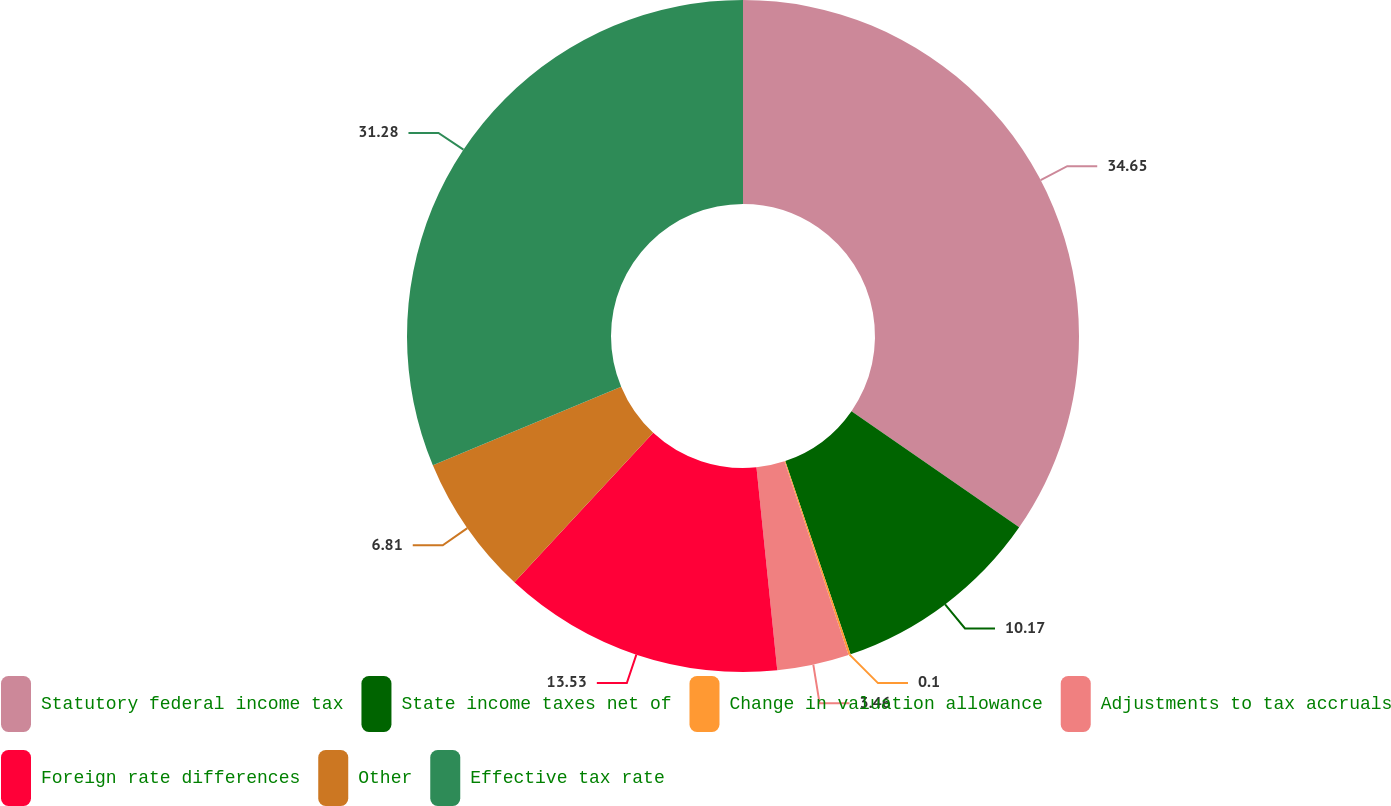<chart> <loc_0><loc_0><loc_500><loc_500><pie_chart><fcel>Statutory federal income tax<fcel>State income taxes net of<fcel>Change in valuation allowance<fcel>Adjustments to tax accruals<fcel>Foreign rate differences<fcel>Other<fcel>Effective tax rate<nl><fcel>34.64%<fcel>10.17%<fcel>0.1%<fcel>3.46%<fcel>13.53%<fcel>6.81%<fcel>31.28%<nl></chart> 